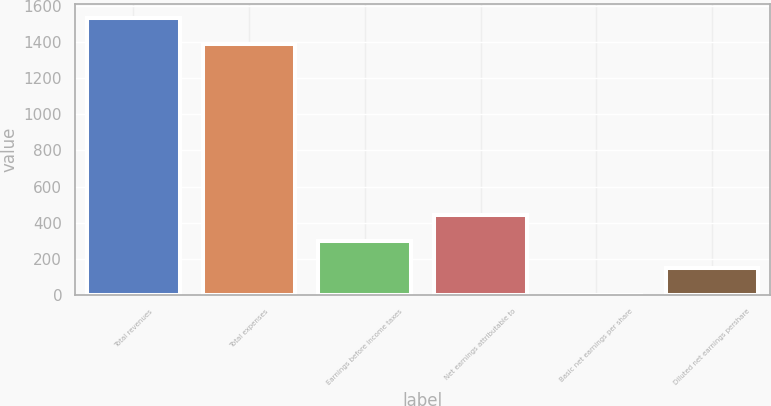<chart> <loc_0><loc_0><loc_500><loc_500><bar_chart><fcel>Total revenues<fcel>Total expenses<fcel>Earnings before income taxes<fcel>Net earnings attributable to<fcel>Basic net earnings per share<fcel>Diluted net earnings pershare<nl><fcel>1535.56<fcel>1387.4<fcel>297.01<fcel>445.17<fcel>0.69<fcel>148.85<nl></chart> 